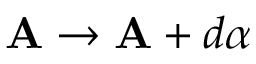<formula> <loc_0><loc_0><loc_500><loc_500>A \rightarrow A + d \alpha</formula> 